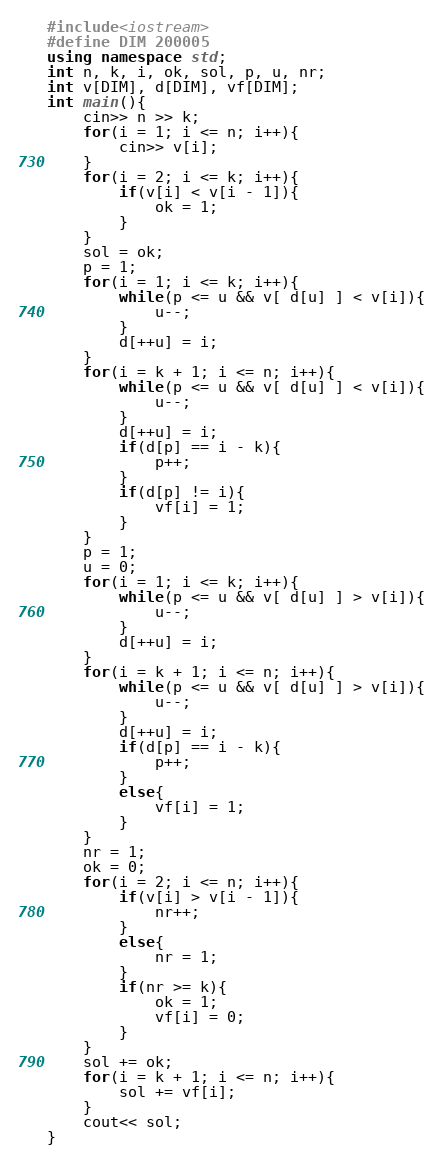Convert code to text. <code><loc_0><loc_0><loc_500><loc_500><_C++_>#include<iostream>
#define DIM 200005
using namespace std;
int n, k, i, ok, sol, p, u, nr;
int v[DIM], d[DIM], vf[DIM];
int main(){
    cin>> n >> k;
    for(i = 1; i <= n; i++){
        cin>> v[i];
    }
    for(i = 2; i <= k; i++){
        if(v[i] < v[i - 1]){
            ok = 1;
        }
    }
    sol = ok;
    p = 1;
    for(i = 1; i <= k; i++){
        while(p <= u && v[ d[u] ] < v[i]){
            u--;
        }
        d[++u] = i;
    }
    for(i = k + 1; i <= n; i++){
        while(p <= u && v[ d[u] ] < v[i]){
            u--;
        }
        d[++u] = i;
        if(d[p] == i - k){
            p++;
        }
        if(d[p] != i){
            vf[i] = 1;
        }
    }
    p = 1;
    u = 0;
    for(i = 1; i <= k; i++){
        while(p <= u && v[ d[u] ] > v[i]){
            u--;
        }
        d[++u] = i;
    }
    for(i = k + 1; i <= n; i++){
        while(p <= u && v[ d[u] ] > v[i]){
            u--;
        }
        d[++u] = i;
        if(d[p] == i - k){
            p++;
        }
        else{
            vf[i] = 1;
        }
    }
    nr = 1;
    ok = 0;
    for(i = 2; i <= n; i++){
        if(v[i] > v[i - 1]){
            nr++;
        }
        else{
            nr = 1;
        }
        if(nr >= k){
            ok = 1;
            vf[i] = 0;
        }
    }
    sol += ok;
    for(i = k + 1; i <= n; i++){
        sol += vf[i];
    }
    cout<< sol;
}
</code> 